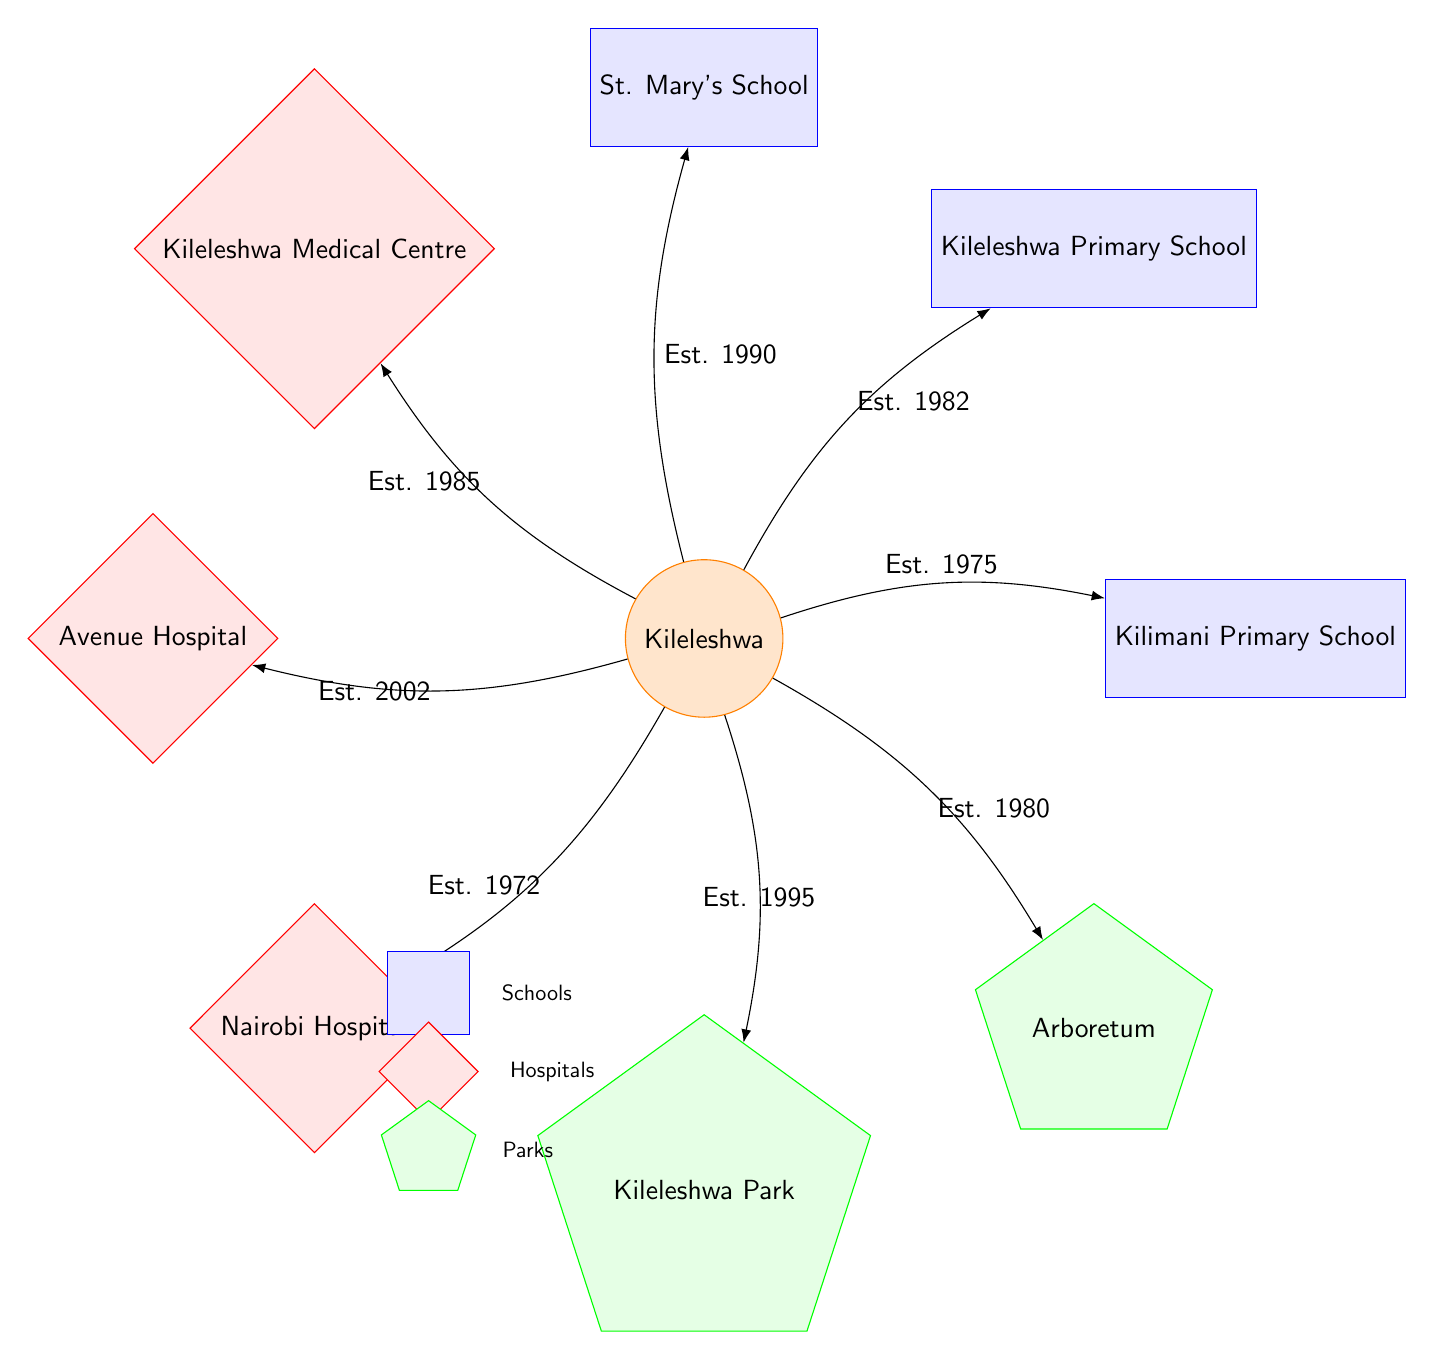What school was established in 1982? By looking at the diagram, we see a direct connection from Kileleshwa to Kileleshwa Primary School with the establishment year labeled as 1982.
Answer: Kileleshwa Primary School How many hospitals are shown in the diagram? The diagram lists three hospital nodes connected to Kileleshwa: Kileleshwa Medical Centre, Avenue Hospital, and Nairobi Hospital. By counting these nodes, we find that there are three hospitals.
Answer: 3 Which park was established in 1995? The diagram indicates a direct connection from Kileleshwa to Kileleshwa Park labeled with the year 1995. Thus, Kileleshwa Park was established in 1995.
Answer: Kileleshwa Park What is the establishment year of St. Mary's School? St. Mary's School has a direct connection to Kileleshwa in the diagram, which specifies its establishment year as 1990.
Answer: 1990 Which facility is located to the right of Kileleshwa? According to the diagram, Avenue Hospital is positioned directly to the left of Kileleshwa, making Kileleshwa Park the facility located to the right.
Answer: Kileleshwa Park What type of infrastructure was opened most recently? To find the most recent type of infrastructure, we can look at the establishment years. The last mentioned establishment is Avenue Hospital, which was built in 2002. Thus, the most recent infrastructure opened is a hospital.
Answer: Hospital How many parks are represented in the diagram? The diagram displays two parks: Kileleshwa Park and Arboretum. Counting these nodes gives us a total of two parks represented.
Answer: 2 Which school was established first according to the diagram? The diagram shows Kilimani Primary School with an establishment year of 1975. By comparing this year with the other schools, we can determine that it is the first established school.
Answer: Kilimani Primary School What relationship do the nodes have with Kileleshwa? Each node (school, hospital, park) is connected to Kileleshwa with arrows indicating they are all established as part of Kileleshwa’s development, forming a community growth network.
Answer: Established network 